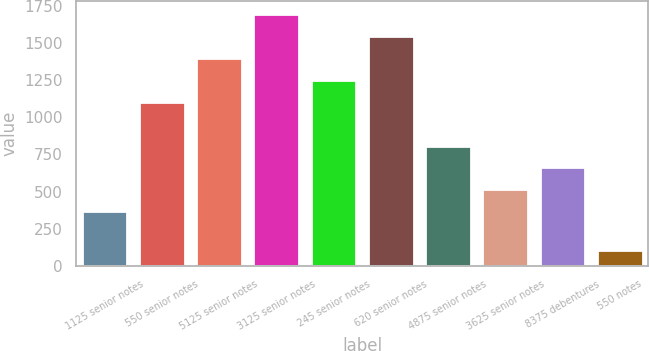<chart> <loc_0><loc_0><loc_500><loc_500><bar_chart><fcel>1125 senior notes<fcel>550 senior notes<fcel>5125 senior notes<fcel>3125 senior notes<fcel>245 senior notes<fcel>620 senior notes<fcel>4875 senior notes<fcel>3625 senior notes<fcel>8375 debentures<fcel>550 notes<nl><fcel>367<fcel>1104<fcel>1398.8<fcel>1693.6<fcel>1251.4<fcel>1546.2<fcel>809.2<fcel>514.4<fcel>661.8<fcel>105<nl></chart> 